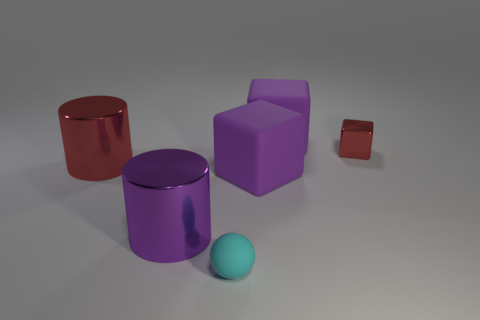Add 3 blue rubber cylinders. How many objects exist? 9 Subtract all cylinders. How many objects are left? 4 Subtract all cyan matte spheres. Subtract all big purple cylinders. How many objects are left? 4 Add 6 matte balls. How many matte balls are left? 7 Add 5 cyan matte objects. How many cyan matte objects exist? 6 Subtract 0 brown balls. How many objects are left? 6 